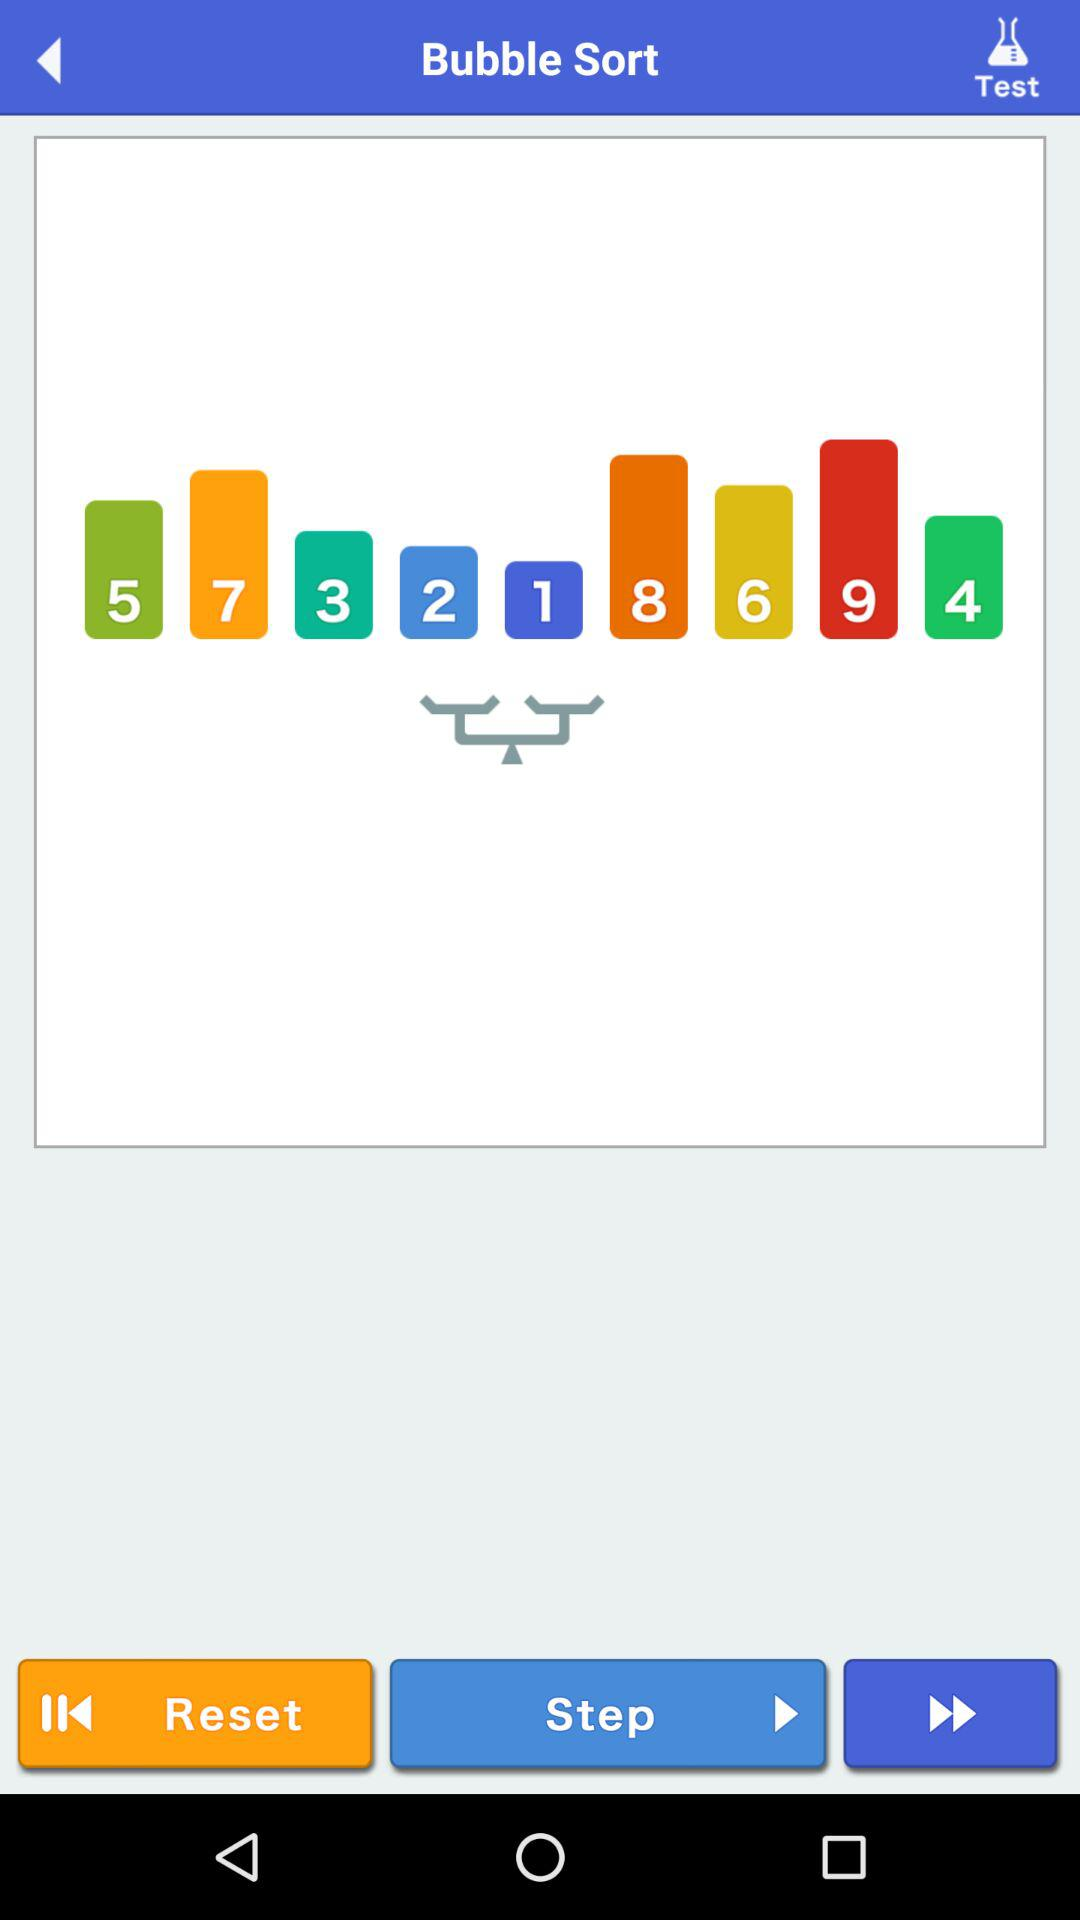What is the application name? The application name is "Bubble Sort". 